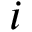Convert formula to latex. <formula><loc_0><loc_0><loc_500><loc_500>i</formula> 